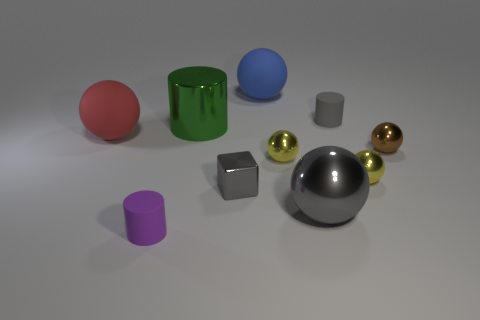Subtract all gray spheres. How many spheres are left? 5 Subtract 2 spheres. How many spheres are left? 4 Subtract all red matte spheres. How many spheres are left? 5 Subtract all cyan spheres. Subtract all cyan blocks. How many spheres are left? 6 Subtract all blocks. How many objects are left? 9 Subtract all spheres. Subtract all green metal cylinders. How many objects are left? 3 Add 6 green shiny things. How many green shiny things are left? 7 Add 1 big metal balls. How many big metal balls exist? 2 Subtract 0 yellow blocks. How many objects are left? 10 